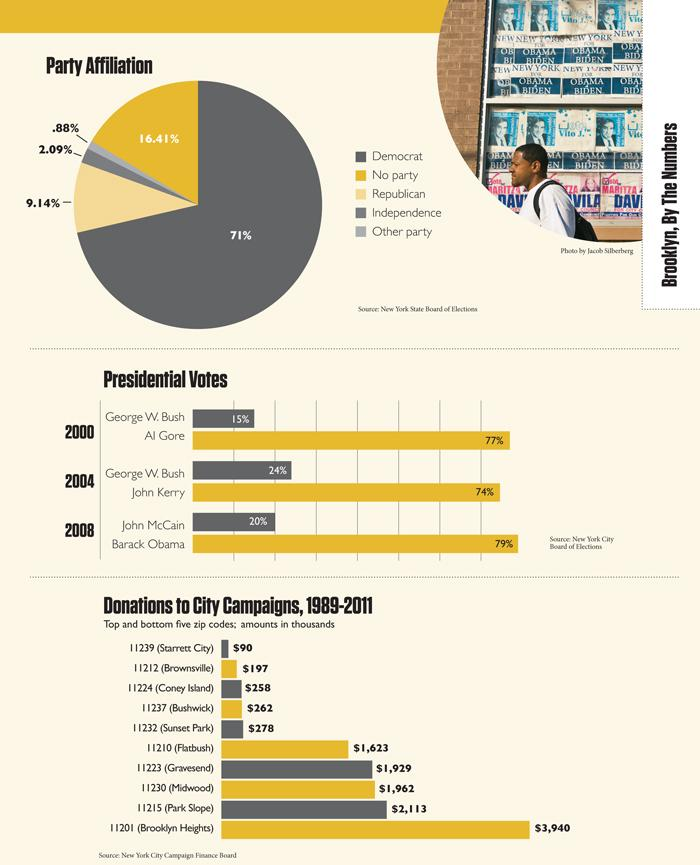Mention a couple of crucial points in this snapshot. Park Slope was the city that received the second highest donations for a campaign from 1989 to 2011. In the pie chart, the total affiliation of Democrats and Republicans combined is 80.14%. Gravesend is located in the zip code 11223. Al Gore received 77% of the presidential vote in 2000. In the year 2008, John McCain received 46.1% of the presidential vote share. 